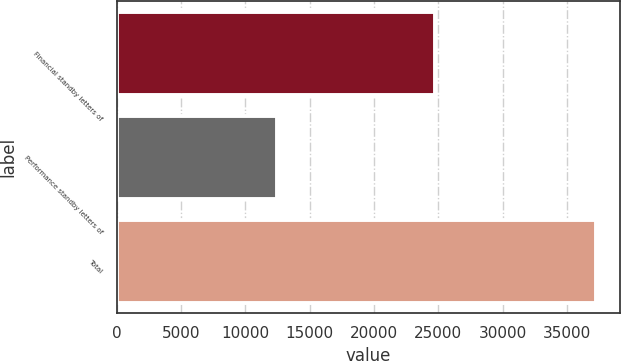<chart> <loc_0><loc_0><loc_500><loc_500><bar_chart><fcel>Financial standby letters of<fcel>Performance standby letters of<fcel>Total<nl><fcel>24779<fcel>12480<fcel>37259<nl></chart> 